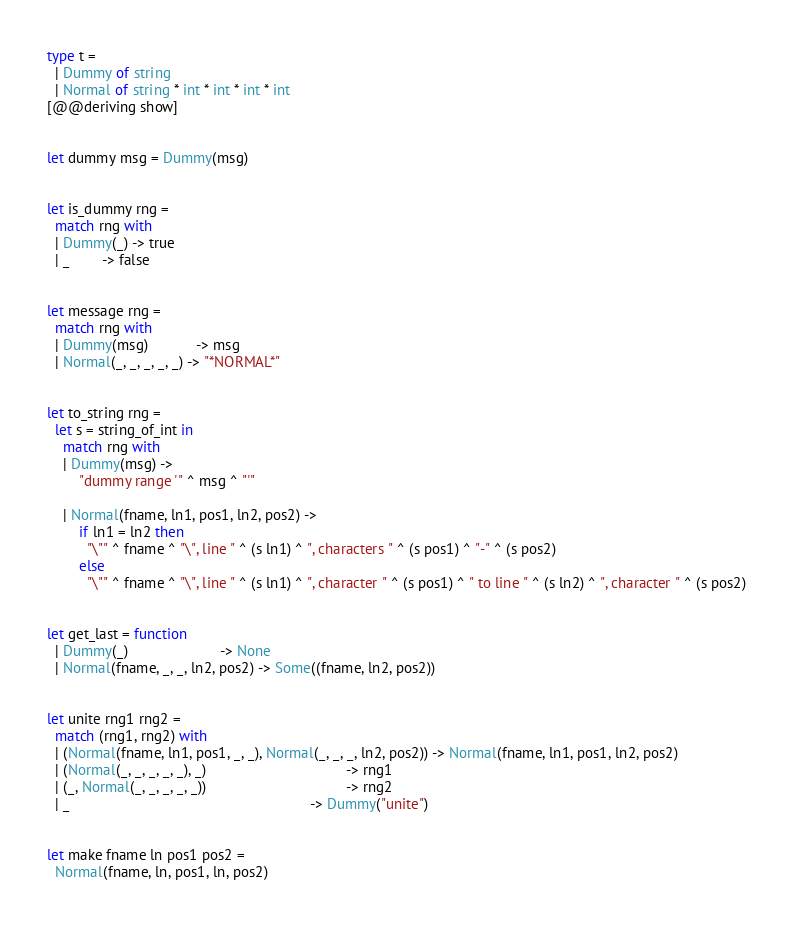<code> <loc_0><loc_0><loc_500><loc_500><_OCaml_>
type t =
  | Dummy of string
  | Normal of string * int * int * int * int
[@@deriving show]


let dummy msg = Dummy(msg)


let is_dummy rng =
  match rng with
  | Dummy(_) -> true
  | _        -> false


let message rng =
  match rng with
  | Dummy(msg)            -> msg
  | Normal(_, _, _, _, _) -> "*NORMAL*"


let to_string rng =
  let s = string_of_int in
    match rng with
    | Dummy(msg) ->
        "dummy range '" ^ msg ^ "'"

    | Normal(fname, ln1, pos1, ln2, pos2) ->
        if ln1 = ln2 then
          "\"" ^ fname ^ "\", line " ^ (s ln1) ^ ", characters " ^ (s pos1) ^ "-" ^ (s pos2)
        else
          "\"" ^ fname ^ "\", line " ^ (s ln1) ^ ", character " ^ (s pos1) ^ " to line " ^ (s ln2) ^ ", character " ^ (s pos2)


let get_last = function
  | Dummy(_)                       -> None
  | Normal(fname, _, _, ln2, pos2) -> Some((fname, ln2, pos2))


let unite rng1 rng2 =
  match (rng1, rng2) with
  | (Normal(fname, ln1, pos1, _, _), Normal(_, _, _, ln2, pos2)) -> Normal(fname, ln1, pos1, ln2, pos2)
  | (Normal(_, _, _, _, _), _)                                   -> rng1
  | (_, Normal(_, _, _, _, _))                                   -> rng2
  | _                                                            -> Dummy("unite")


let make fname ln pos1 pos2 =
  Normal(fname, ln, pos1, ln, pos2)

</code> 